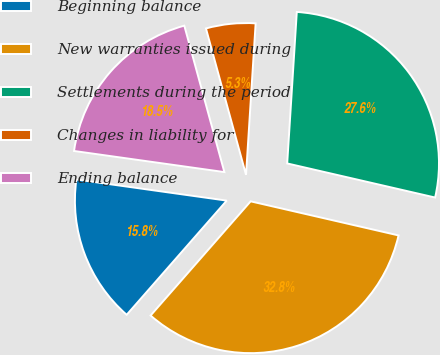Convert chart. <chart><loc_0><loc_0><loc_500><loc_500><pie_chart><fcel>Beginning balance<fcel>New warranties issued during<fcel>Settlements during the period<fcel>Changes in liability for<fcel>Ending balance<nl><fcel>15.77%<fcel>32.85%<fcel>27.6%<fcel>5.26%<fcel>18.53%<nl></chart> 